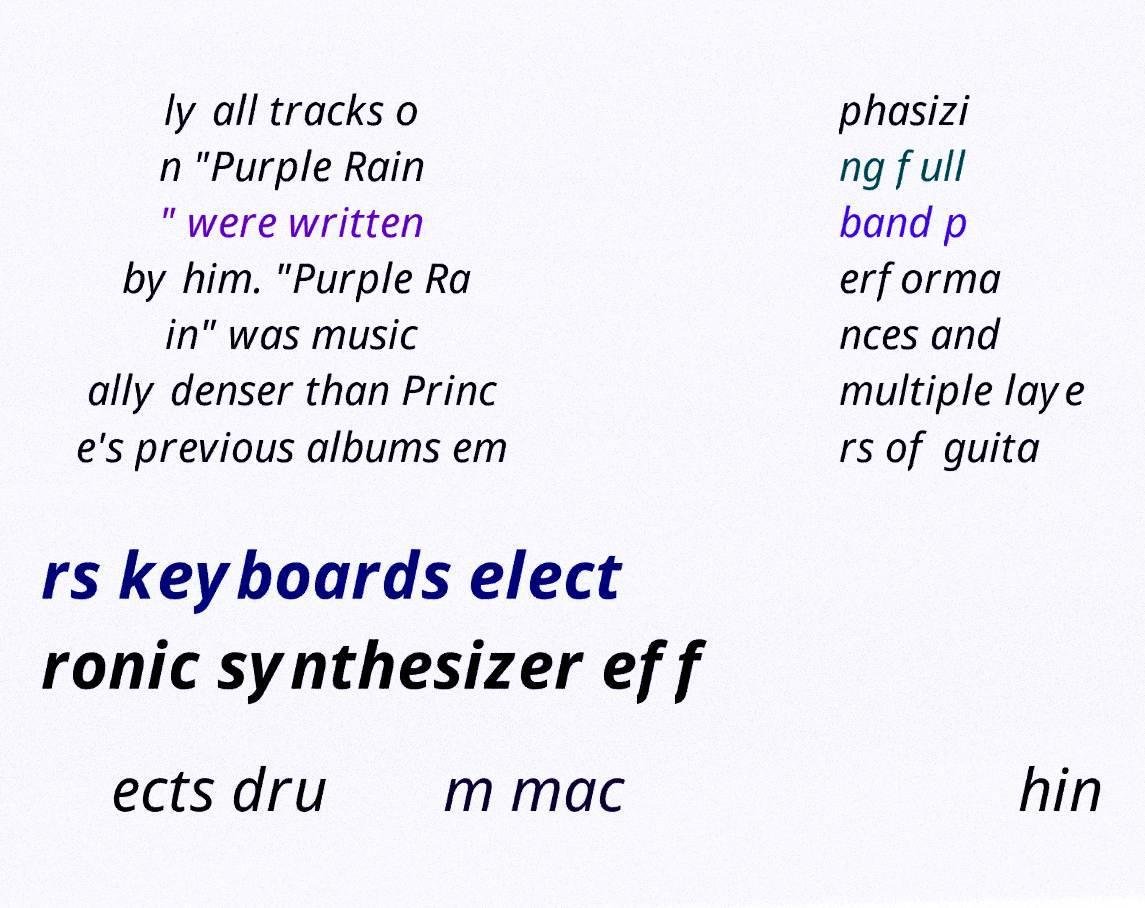Could you assist in decoding the text presented in this image and type it out clearly? ly all tracks o n "Purple Rain " were written by him. "Purple Ra in" was music ally denser than Princ e's previous albums em phasizi ng full band p erforma nces and multiple laye rs of guita rs keyboards elect ronic synthesizer eff ects dru m mac hin 